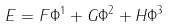<formula> <loc_0><loc_0><loc_500><loc_500>E = F \Phi ^ { 1 } + G \Phi ^ { 2 } + H \Phi ^ { 3 }</formula> 